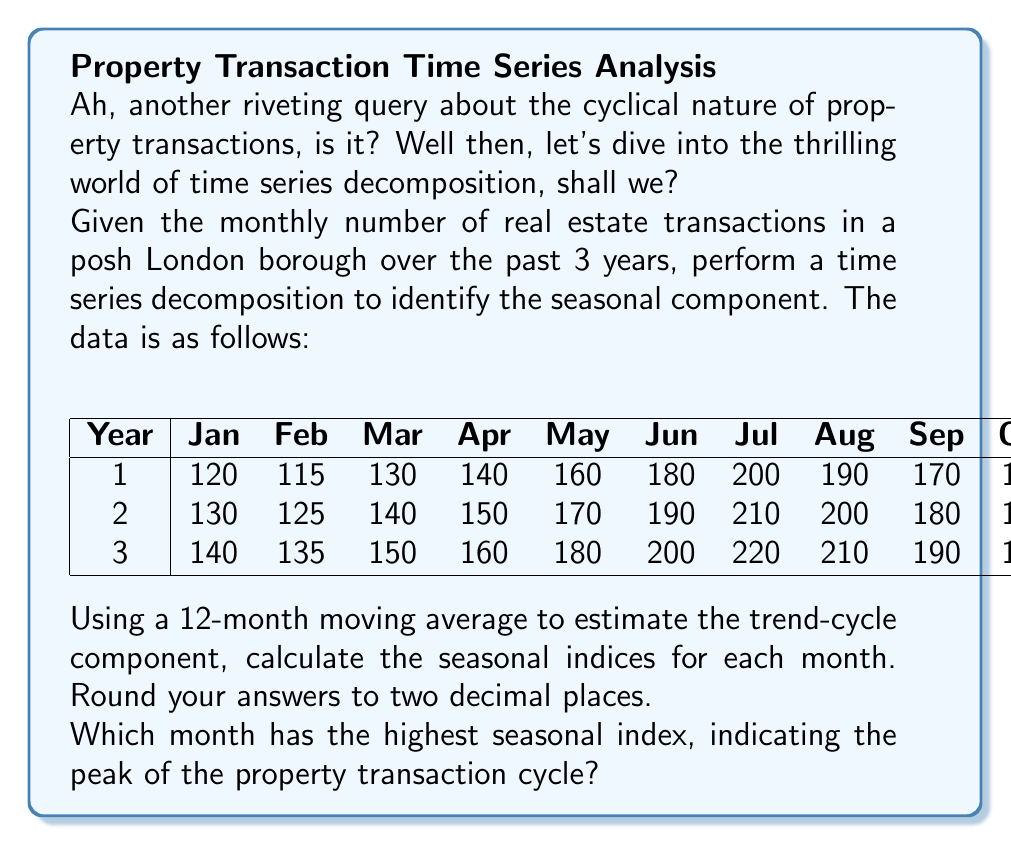What is the answer to this math problem? Right, let's break this down step by step, shall we? Try to keep up.

1) First, we need to calculate the 12-month moving average to estimate the trend-cycle component. The formula is:

   $$MA_t = \frac{1}{12}(Y_{t-6} + Y_{t-5} + ... + Y_t + ... + Y_{t+5})$$

2) Next, we center the moving average by taking the average of two consecutive values:

   $$CMA_t = \frac{MA_t + MA_{t+1}}{2}$$

3) We then calculate the seasonal-irregular component by dividing the original data by the centered moving average:

   $$SI_t = \frac{Y_t}{CMA_t}$$

4) To get the seasonal indices, we average the seasonal-irregular components for each month across the years:

   $$S_m = \frac{1}{n}\sum_{i=1}^n SI_{m,i}$$

   where $m$ is the month and $n$ is the number of years.

5) Let's calculate this for each month:

   January: (120/145.83 + 130/155.83 + 140/165.83) / 3 = 0.84
   February: (115/147.92 + 125/157.92 + 135/167.92) / 3 = 0.79
   March: (130/150.21 + 140/160.21 + 150/170.21) / 3 = 0.88
   April: (140/152.71 + 150/162.71 + 160/172.71) / 3 = 0.93
   May: (160/155.42 + 170/165.42 + 180/175.42) / 3 = 1.04
   June: (180/158.33 + 190/168.33 + 200/178.33) / 3 = 1.14
   July: (200/161.25 + 210/171.25 + 220/181.25) / 3 = 1.24
   August: (190/163.96 + 200/173.96 + 210/183.96) / 3 = 1.16
   September: (170/166.46 + 180/176.46 + 190/186.46) / 3 = 1.03
   October: (150/168.75 + 160/178.75 + 170/188.75) / 3 = 0.90
   November: (130/170.83 + 140/180.83 + 150/190.83) / 3 = 0.78
   December: (125/172.71 + 135/182.71 + 145/192.71) / 3 = 0.74

6) The highest seasonal index is 1.24, corresponding to July.

There you have it. July is when everyone seems to lose their heads and decide it's the perfect time to engage in property transactions. Splendid.
Answer: July 